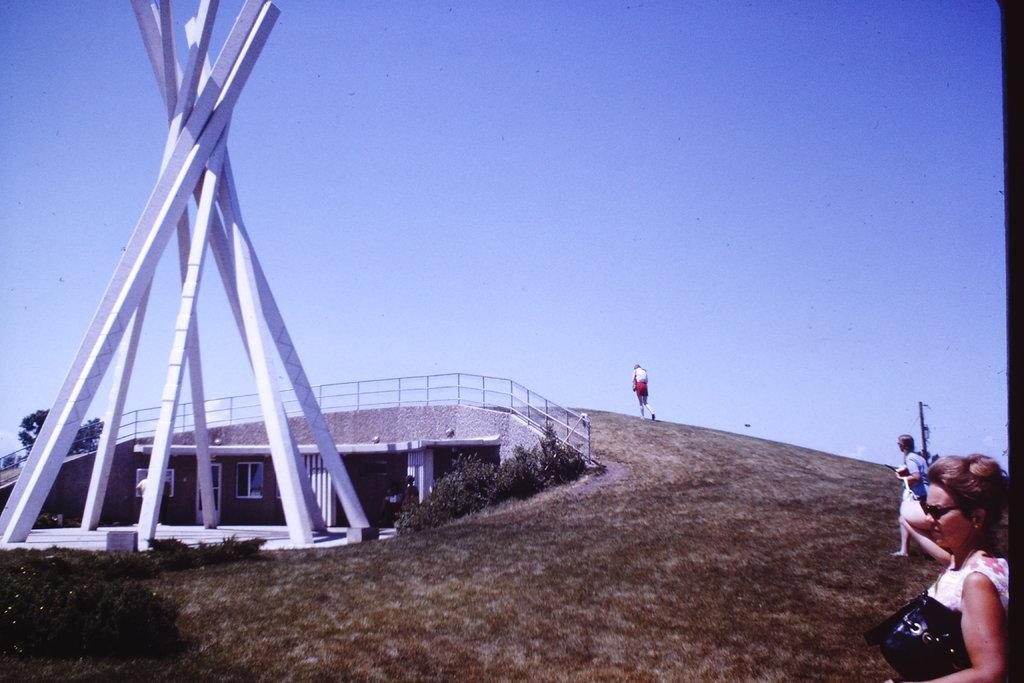How many people are in the image? There are three persons in the left corner of the image. What structure can be seen in the left corner of the image? There is a bridge in the left corner of the image. What else is present in the left corner of the image? There is another object in the left corner of the image. What month is displayed on the calendar in the image? There is no calendar present in the image. Can you tell me how many chickens are on the bridge in the image? There are no chickens present in the image, and the bridge is the only structure mentioned in the facts. 